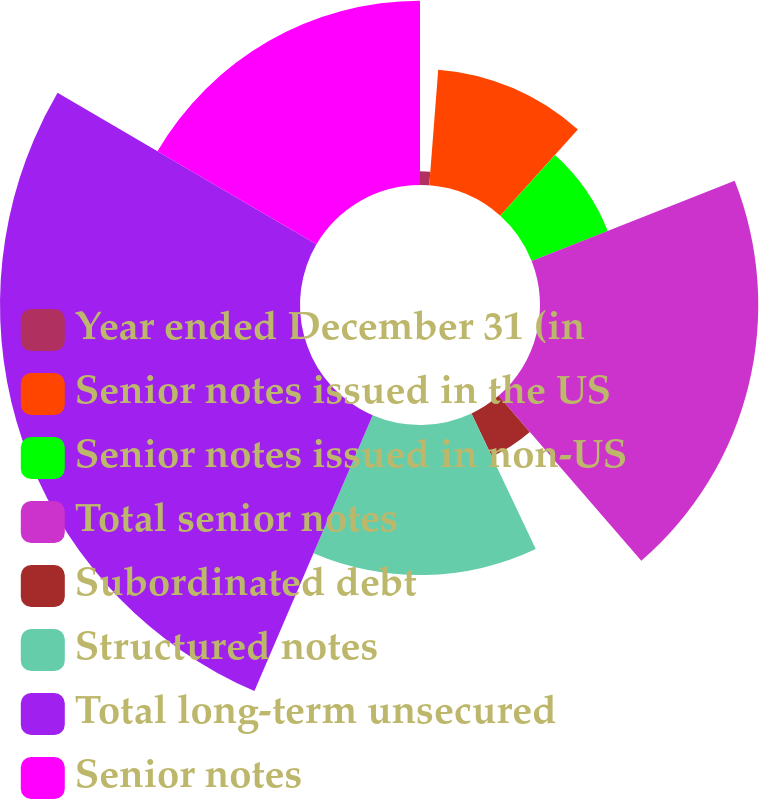Convert chart to OTSL. <chart><loc_0><loc_0><loc_500><loc_500><pie_chart><fcel>Year ended December 31 (in<fcel>Senior notes issued in the US<fcel>Senior notes issued in non-US<fcel>Total senior notes<fcel>Subordinated debt<fcel>Structured notes<fcel>Total long-term unsecured<fcel>Senior notes<nl><fcel>1.23%<fcel>10.43%<fcel>7.36%<fcel>19.63%<fcel>4.3%<fcel>13.5%<fcel>26.98%<fcel>16.57%<nl></chart> 